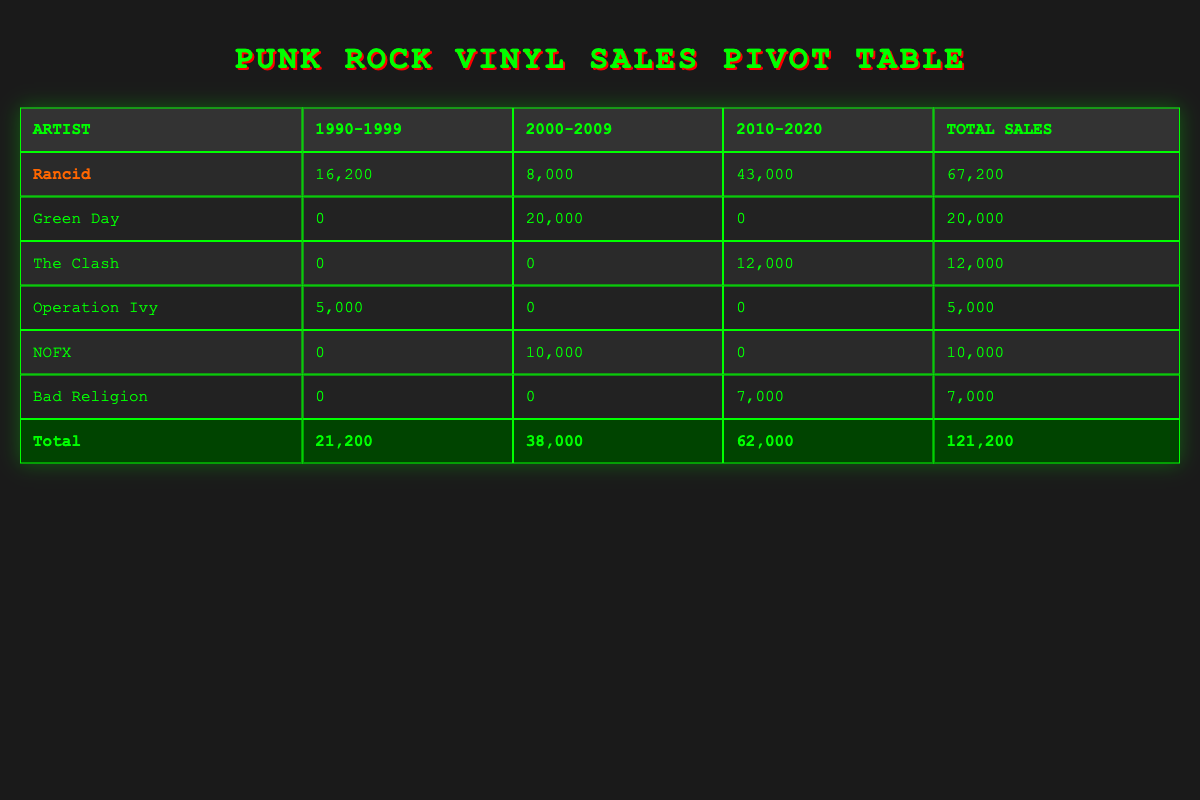What is Rancid's total sales from 1990 to 1999? Looking at the sales for Rancid in the years 1990-1999, we see sales of 1200 in 1990 and 15000 in 1995. Adding these values together, 1200 + 15000 = 16200.
Answer: 16200 Which artist had the highest total sales? Looking at the total sales column for each artist, Rancid has total sales of 67200, which is greater than any other artist's total sales.
Answer: Rancid How many records did Green Day sell between 2000 and 2009? Green Day's only sales during 2000-2009 occurred in the year 2000, with 20000 sales for the album "Dookie." No other sales are recorded for this artist in that period.
Answer: 20000 Did Operation Ivy sell more records in the 1990s than NOFX did in the 2000s? Operation Ivy has total sales of 5000 in the 1990s. NOFX has total sales of 10000 in the 2000s. Comparing these values, 5000 is less than 10000. Hence, the answer is no.
Answer: No What is the average sales for Rancid records in the 2010-2020 period? Rancid has sales of 43000 in the period from 2010 to 2020. There are three records from Rancid in this timeframe (one in 2015 and two in 2020). Therefore, to find the average, we divide the total sales by the number of records: 43000 / 2 = 21500.
Answer: 21500 Which decade saw more total sales for The Clash? The Clash had sales of 12000 only in the 2010-2020 decade. There are no records from The Clash in the 1990-1999 or 2000-2009 decades, so the answer is the 2010-2020 decade saw all their sales.
Answer: 2010-2020 What percentage of total sales did Bad Religion account for in the entire table? Bad Religion has sales of 7000, while the total sales across all artists is 121200. To find the percentage, we calculate (7000 / 121200) * 100, which equals approximately 5.78%.
Answer: 5.78% Is Rancid's sales in the 2010-2020 period higher than the total sales of Green Day? Rancid's total sales for the 2010-2020 period is 43000. Green Day's total sales is 20000 (from the 2000-2009 period). Comparing these numbers, 43000 is greater than 20000. Therefore, the answer is yes.
Answer: Yes 